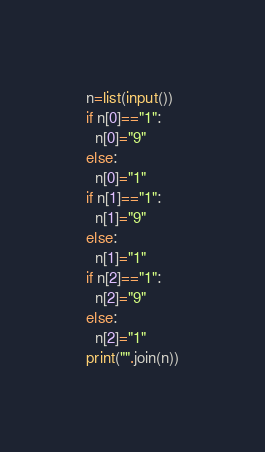<code> <loc_0><loc_0><loc_500><loc_500><_Python_>n=list(input())
if n[0]=="1":
  n[0]="9"
else:
  n[0]="1"
if n[1]=="1":
  n[1]="9"
else:
  n[1]="1"
if n[2]=="1":
  n[2]="9"
else:
  n[2]="1"
print("".join(n))</code> 